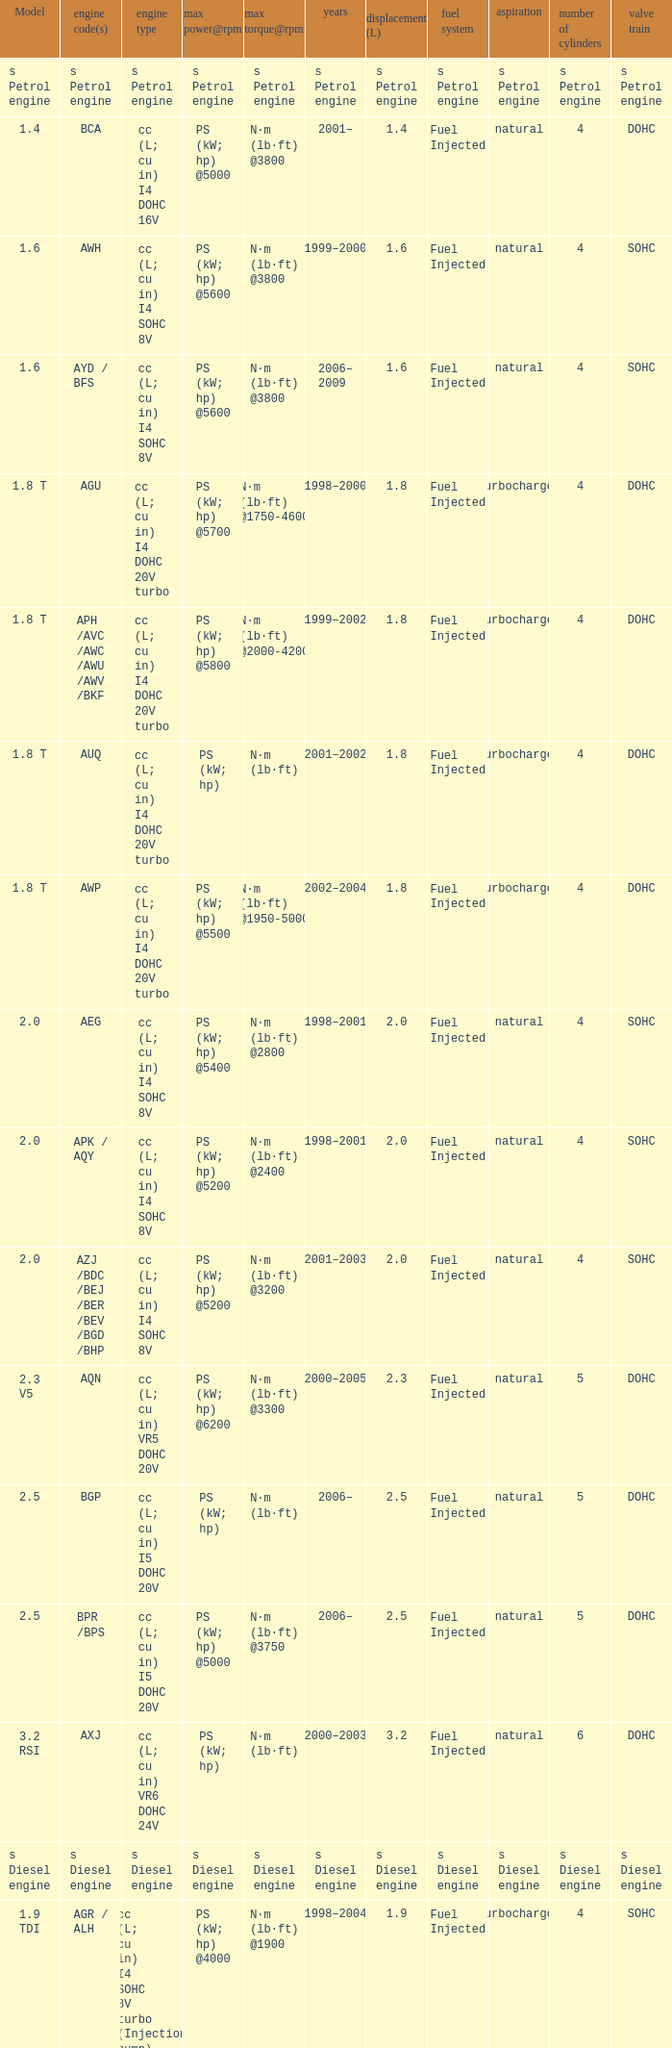Which engine type was used in the model 2.3 v5? Cc (l; cu in) vr5 dohc 20v. 